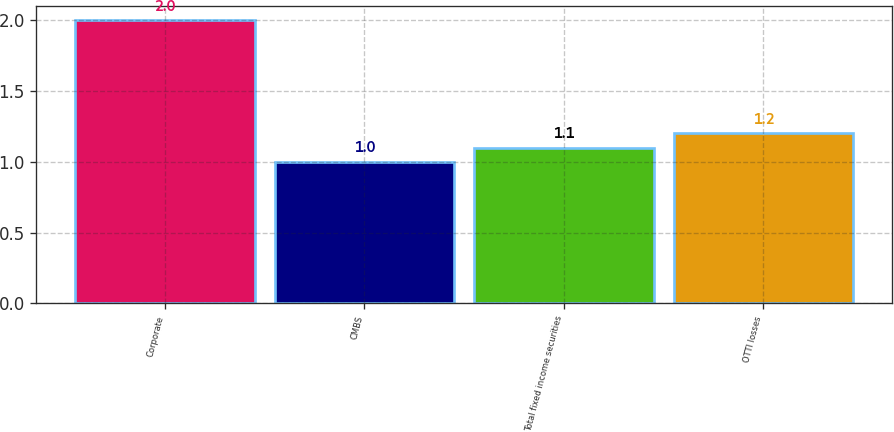Convert chart. <chart><loc_0><loc_0><loc_500><loc_500><bar_chart><fcel>Corporate<fcel>CMBS<fcel>Total fixed income securities<fcel>OTTI losses<nl><fcel>2<fcel>1<fcel>1.1<fcel>1.2<nl></chart> 